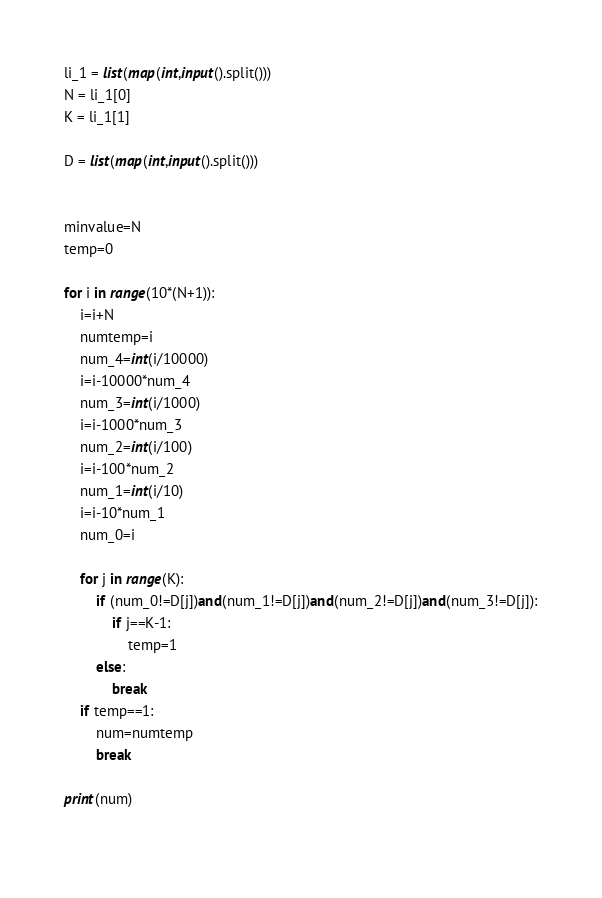Convert code to text. <code><loc_0><loc_0><loc_500><loc_500><_Python_>li_1 = list(map(int,input().split()))
N = li_1[0]
K = li_1[1]

D = list(map(int,input().split()))


minvalue=N
temp=0

for i in range(10*(N+1)):
    i=i+N
    numtemp=i
    num_4=int(i/10000)
    i=i-10000*num_4
    num_3=int(i/1000)
    i=i-1000*num_3
    num_2=int(i/100)
    i=i-100*num_2
    num_1=int(i/10)
    i=i-10*num_1
    num_0=i
    
    for j in range(K):
        if (num_0!=D[j])and(num_1!=D[j])and(num_2!=D[j])and(num_3!=D[j]):
            if j==K-1:
                temp=1
        else:
            break
    if temp==1:
        num=numtemp
        break

print(num)
    </code> 